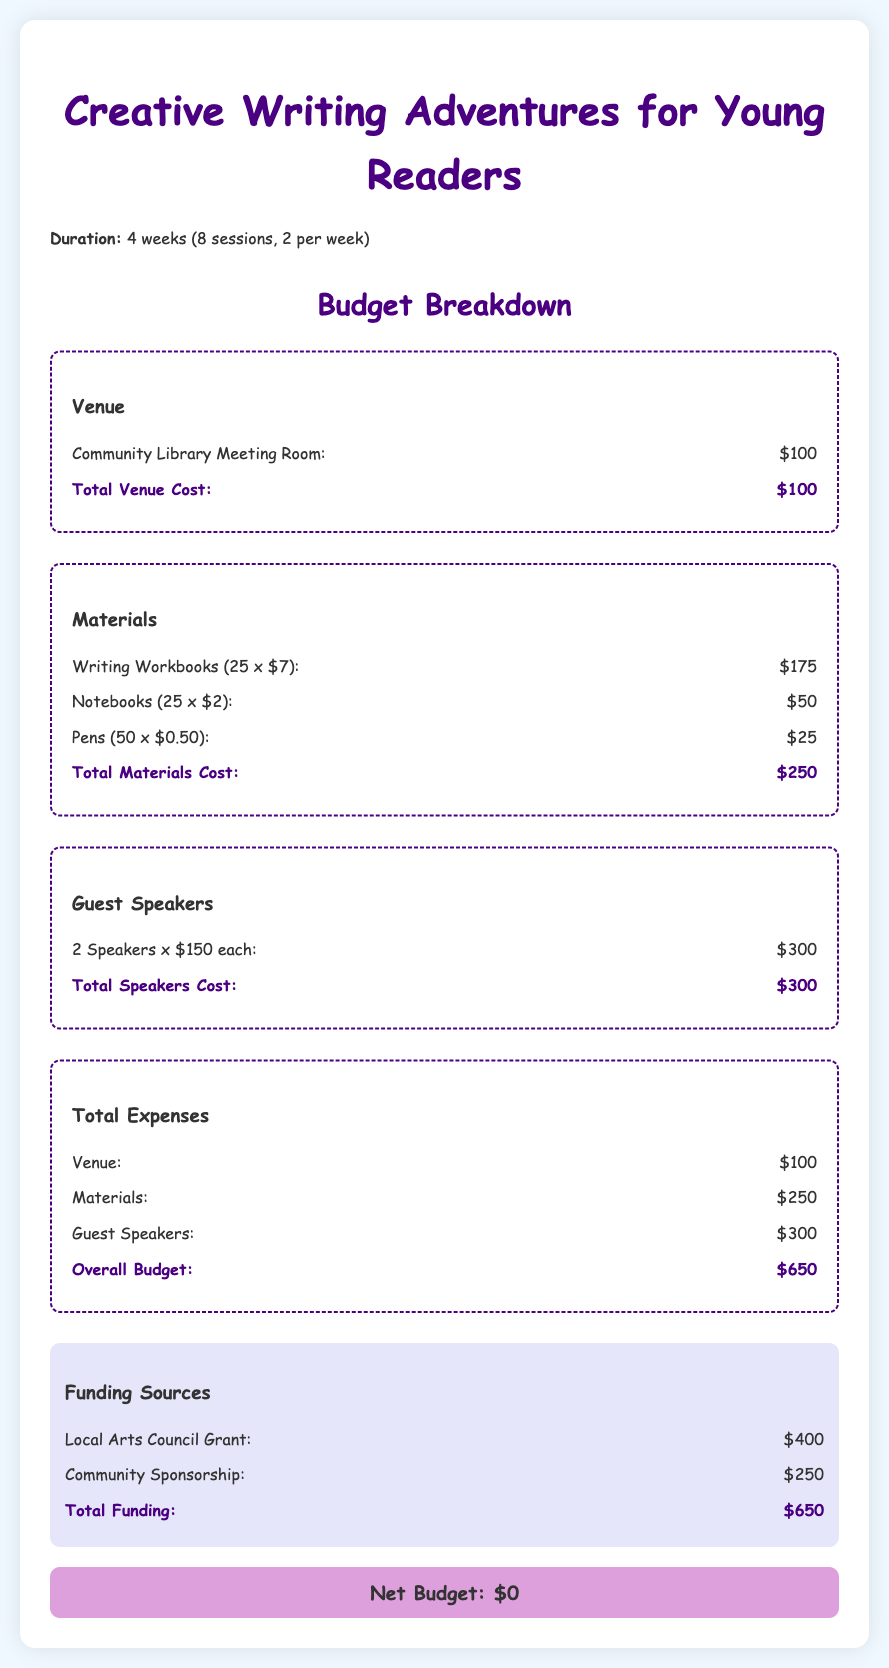What is the duration of the workshops? The duration of the workshops is specified as 4 weeks, covering 8 sessions in total.
Answer: 4 weeks What is the total cost for materials? The total cost for materials is detailed in the budget section and sums up all material expenses.
Answer: $250 How much is allocated for guest speakers? The allocation for guest speakers is provided in the guest speakers section of the budget breakdown.
Answer: $300 What is the total venue cost? The total cost for the venue is stated clearly in the venue section of the document.
Answer: $100 How many guest speakers are invited? The number of guest speakers is mentioned along with their total cost in the guest speakers section.
Answer: 2 speakers What is the overall budget for the workshops? The overall budget is presented in the total expenses section that sums up all costs.
Answer: $650 What is the net budget after funding? The net budget is calculated by considering total expenses against total funding, which is shown at the end.
Answer: $0 What is the source of the largest funding? The largest funding source is highlighted in the funding sources section of the budget.
Answer: Local Arts Council Grant What type of venue is rented? The document specifies the type of venue included in the budget for the workshops.
Answer: Community Library Meeting Room 